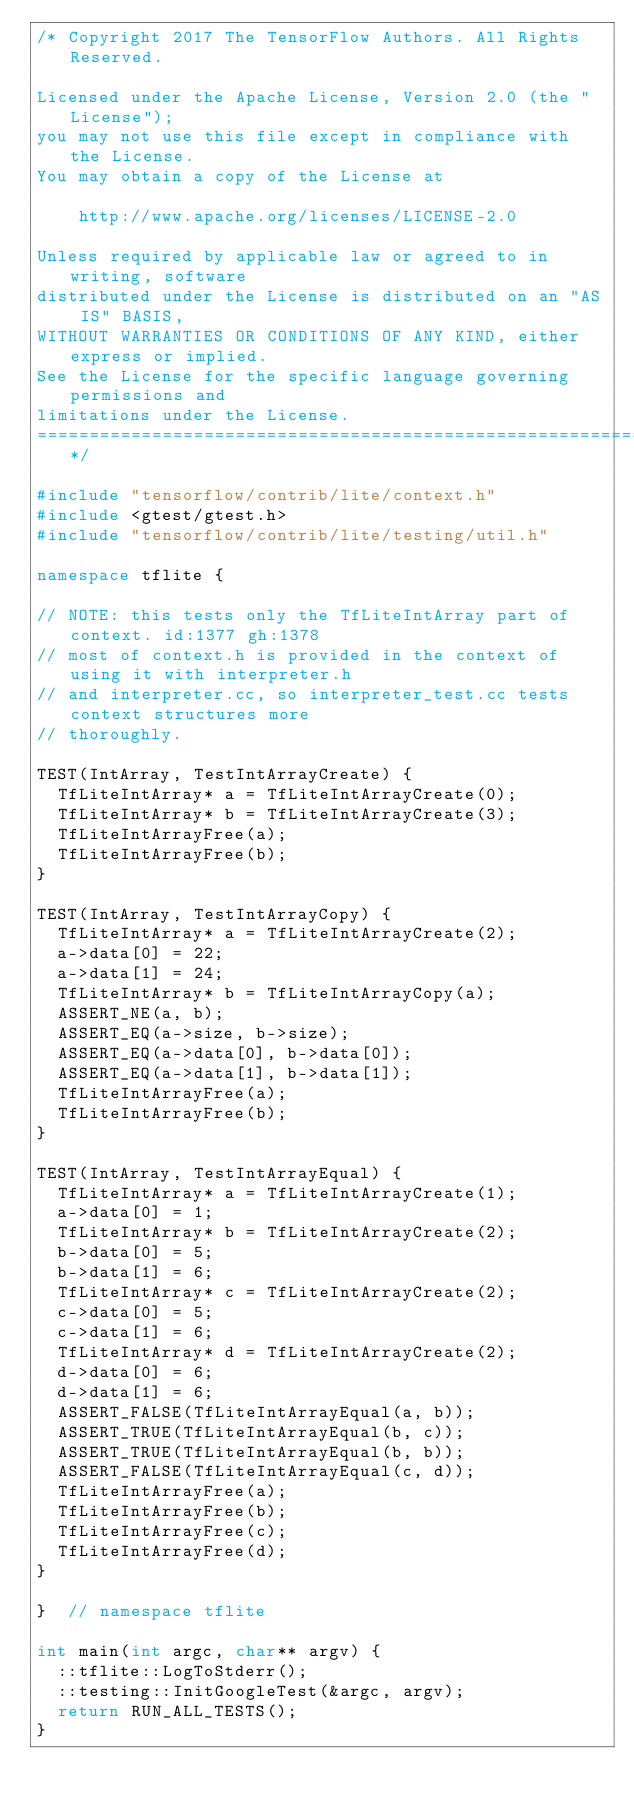Convert code to text. <code><loc_0><loc_0><loc_500><loc_500><_C++_>/* Copyright 2017 The TensorFlow Authors. All Rights Reserved.

Licensed under the Apache License, Version 2.0 (the "License");
you may not use this file except in compliance with the License.
You may obtain a copy of the License at

    http://www.apache.org/licenses/LICENSE-2.0

Unless required by applicable law or agreed to in writing, software
distributed under the License is distributed on an "AS IS" BASIS,
WITHOUT WARRANTIES OR CONDITIONS OF ANY KIND, either express or implied.
See the License for the specific language governing permissions and
limitations under the License.
==============================================================================*/

#include "tensorflow/contrib/lite/context.h"
#include <gtest/gtest.h>
#include "tensorflow/contrib/lite/testing/util.h"

namespace tflite {

// NOTE: this tests only the TfLiteIntArray part of context. id:1377 gh:1378
// most of context.h is provided in the context of using it with interpreter.h
// and interpreter.cc, so interpreter_test.cc tests context structures more
// thoroughly.

TEST(IntArray, TestIntArrayCreate) {
  TfLiteIntArray* a = TfLiteIntArrayCreate(0);
  TfLiteIntArray* b = TfLiteIntArrayCreate(3);
  TfLiteIntArrayFree(a);
  TfLiteIntArrayFree(b);
}

TEST(IntArray, TestIntArrayCopy) {
  TfLiteIntArray* a = TfLiteIntArrayCreate(2);
  a->data[0] = 22;
  a->data[1] = 24;
  TfLiteIntArray* b = TfLiteIntArrayCopy(a);
  ASSERT_NE(a, b);
  ASSERT_EQ(a->size, b->size);
  ASSERT_EQ(a->data[0], b->data[0]);
  ASSERT_EQ(a->data[1], b->data[1]);
  TfLiteIntArrayFree(a);
  TfLiteIntArrayFree(b);
}

TEST(IntArray, TestIntArrayEqual) {
  TfLiteIntArray* a = TfLiteIntArrayCreate(1);
  a->data[0] = 1;
  TfLiteIntArray* b = TfLiteIntArrayCreate(2);
  b->data[0] = 5;
  b->data[1] = 6;
  TfLiteIntArray* c = TfLiteIntArrayCreate(2);
  c->data[0] = 5;
  c->data[1] = 6;
  TfLiteIntArray* d = TfLiteIntArrayCreate(2);
  d->data[0] = 6;
  d->data[1] = 6;
  ASSERT_FALSE(TfLiteIntArrayEqual(a, b));
  ASSERT_TRUE(TfLiteIntArrayEqual(b, c));
  ASSERT_TRUE(TfLiteIntArrayEqual(b, b));
  ASSERT_FALSE(TfLiteIntArrayEqual(c, d));
  TfLiteIntArrayFree(a);
  TfLiteIntArrayFree(b);
  TfLiteIntArrayFree(c);
  TfLiteIntArrayFree(d);
}

}  // namespace tflite

int main(int argc, char** argv) {
  ::tflite::LogToStderr();
  ::testing::InitGoogleTest(&argc, argv);
  return RUN_ALL_TESTS();
}
</code> 